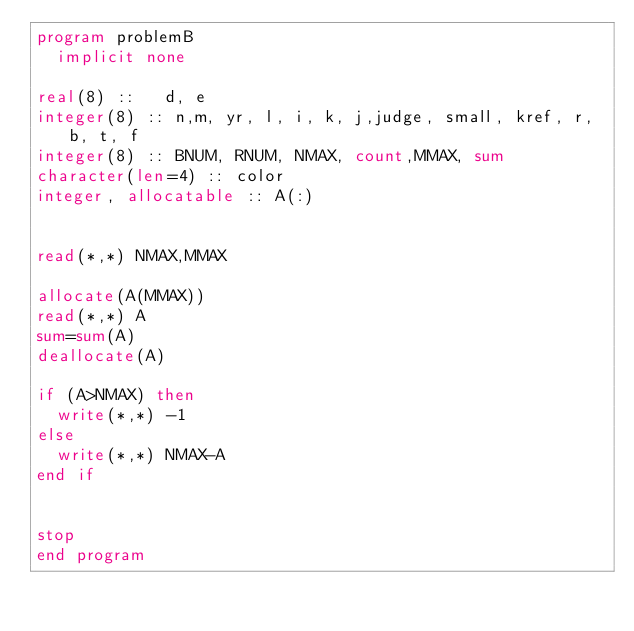<code> <loc_0><loc_0><loc_500><loc_500><_FORTRAN_>program problemB
  implicit none

real(8) ::   d, e
integer(8) :: n,m, yr, l, i, k, j,judge, small, kref, r, b, t, f
integer(8) :: BNUM, RNUM, NMAX, count,MMAX, sum
character(len=4) :: color
integer, allocatable :: A(:)


read(*,*) NMAX,MMAX

allocate(A(MMAX))
read(*,*) A
sum=sum(A)
deallocate(A)

if (A>NMAX) then
  write(*,*) -1
else
  write(*,*) NMAX-A
end if


stop
end program
</code> 